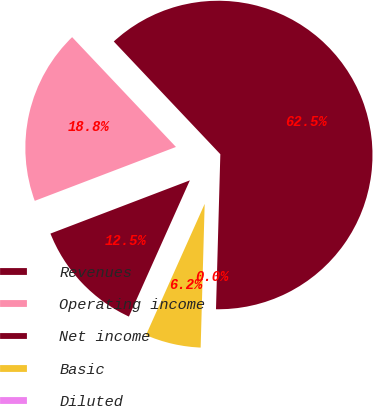Convert chart. <chart><loc_0><loc_0><loc_500><loc_500><pie_chart><fcel>Revenues<fcel>Operating income<fcel>Net income<fcel>Basic<fcel>Diluted<nl><fcel>62.5%<fcel>18.75%<fcel>12.5%<fcel>6.25%<fcel>0.0%<nl></chart> 